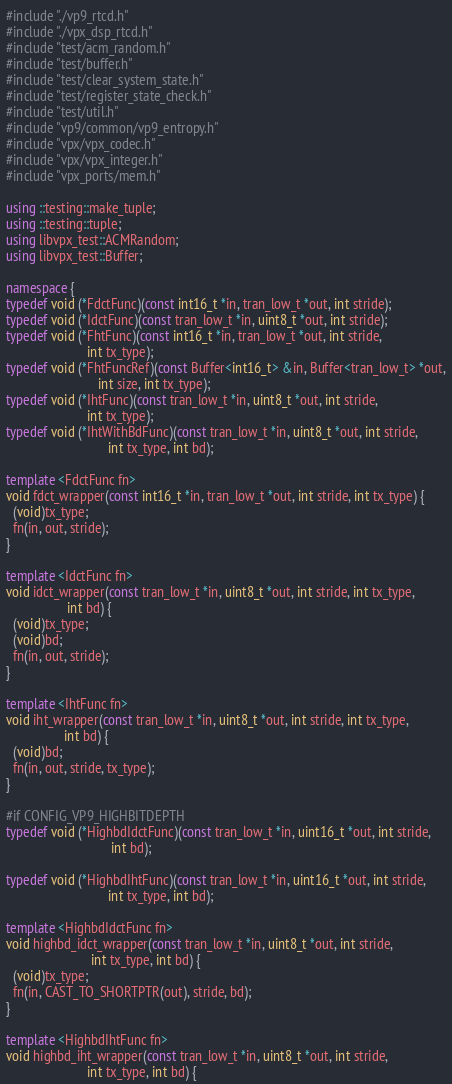<code> <loc_0><loc_0><loc_500><loc_500><_C++_>#include "./vp9_rtcd.h"
#include "./vpx_dsp_rtcd.h"
#include "test/acm_random.h"
#include "test/buffer.h"
#include "test/clear_system_state.h"
#include "test/register_state_check.h"
#include "test/util.h"
#include "vp9/common/vp9_entropy.h"
#include "vpx/vpx_codec.h"
#include "vpx/vpx_integer.h"
#include "vpx_ports/mem.h"

using ::testing::make_tuple;
using ::testing::tuple;
using libvpx_test::ACMRandom;
using libvpx_test::Buffer;

namespace {
typedef void (*FdctFunc)(const int16_t *in, tran_low_t *out, int stride);
typedef void (*IdctFunc)(const tran_low_t *in, uint8_t *out, int stride);
typedef void (*FhtFunc)(const int16_t *in, tran_low_t *out, int stride,
                        int tx_type);
typedef void (*FhtFuncRef)(const Buffer<int16_t> &in, Buffer<tran_low_t> *out,
                           int size, int tx_type);
typedef void (*IhtFunc)(const tran_low_t *in, uint8_t *out, int stride,
                        int tx_type);
typedef void (*IhtWithBdFunc)(const tran_low_t *in, uint8_t *out, int stride,
                              int tx_type, int bd);

template <FdctFunc fn>
void fdct_wrapper(const int16_t *in, tran_low_t *out, int stride, int tx_type) {
  (void)tx_type;
  fn(in, out, stride);
}

template <IdctFunc fn>
void idct_wrapper(const tran_low_t *in, uint8_t *out, int stride, int tx_type,
                  int bd) {
  (void)tx_type;
  (void)bd;
  fn(in, out, stride);
}

template <IhtFunc fn>
void iht_wrapper(const tran_low_t *in, uint8_t *out, int stride, int tx_type,
                 int bd) {
  (void)bd;
  fn(in, out, stride, tx_type);
}

#if CONFIG_VP9_HIGHBITDEPTH
typedef void (*HighbdIdctFunc)(const tran_low_t *in, uint16_t *out, int stride,
                               int bd);

typedef void (*HighbdIhtFunc)(const tran_low_t *in, uint16_t *out, int stride,
                              int tx_type, int bd);

template <HighbdIdctFunc fn>
void highbd_idct_wrapper(const tran_low_t *in, uint8_t *out, int stride,
                         int tx_type, int bd) {
  (void)tx_type;
  fn(in, CAST_TO_SHORTPTR(out), stride, bd);
}

template <HighbdIhtFunc fn>
void highbd_iht_wrapper(const tran_low_t *in, uint8_t *out, int stride,
                        int tx_type, int bd) {</code> 